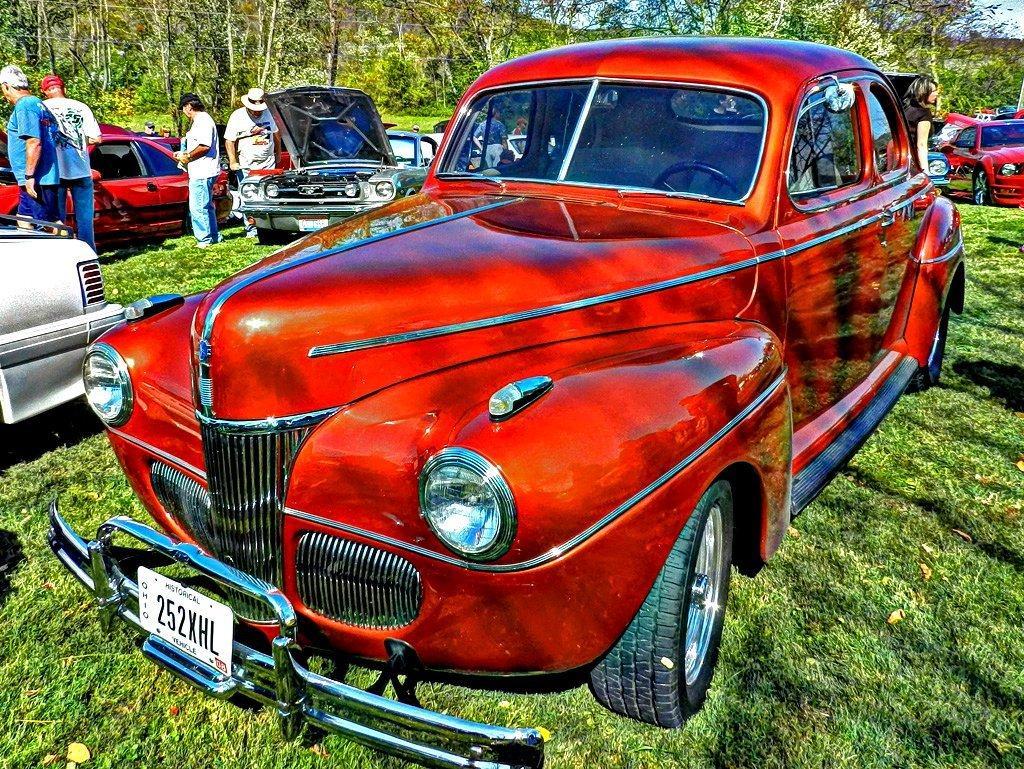Could you give a brief overview of what you see in this image? In this image we can see cars and there are people. At the bottom there is grass. In the background there are trees and sky. 